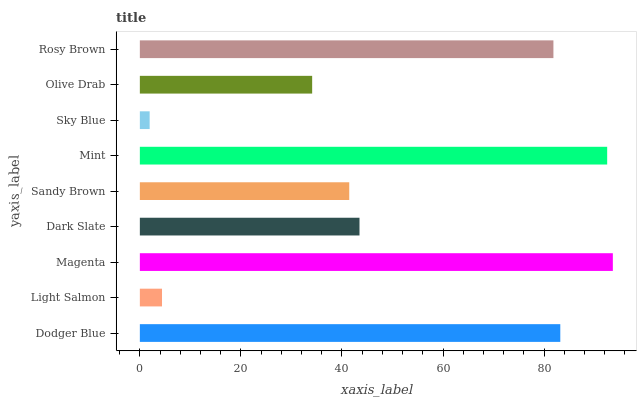Is Sky Blue the minimum?
Answer yes or no. Yes. Is Magenta the maximum?
Answer yes or no. Yes. Is Light Salmon the minimum?
Answer yes or no. No. Is Light Salmon the maximum?
Answer yes or no. No. Is Dodger Blue greater than Light Salmon?
Answer yes or no. Yes. Is Light Salmon less than Dodger Blue?
Answer yes or no. Yes. Is Light Salmon greater than Dodger Blue?
Answer yes or no. No. Is Dodger Blue less than Light Salmon?
Answer yes or no. No. Is Dark Slate the high median?
Answer yes or no. Yes. Is Dark Slate the low median?
Answer yes or no. Yes. Is Dodger Blue the high median?
Answer yes or no. No. Is Magenta the low median?
Answer yes or no. No. 